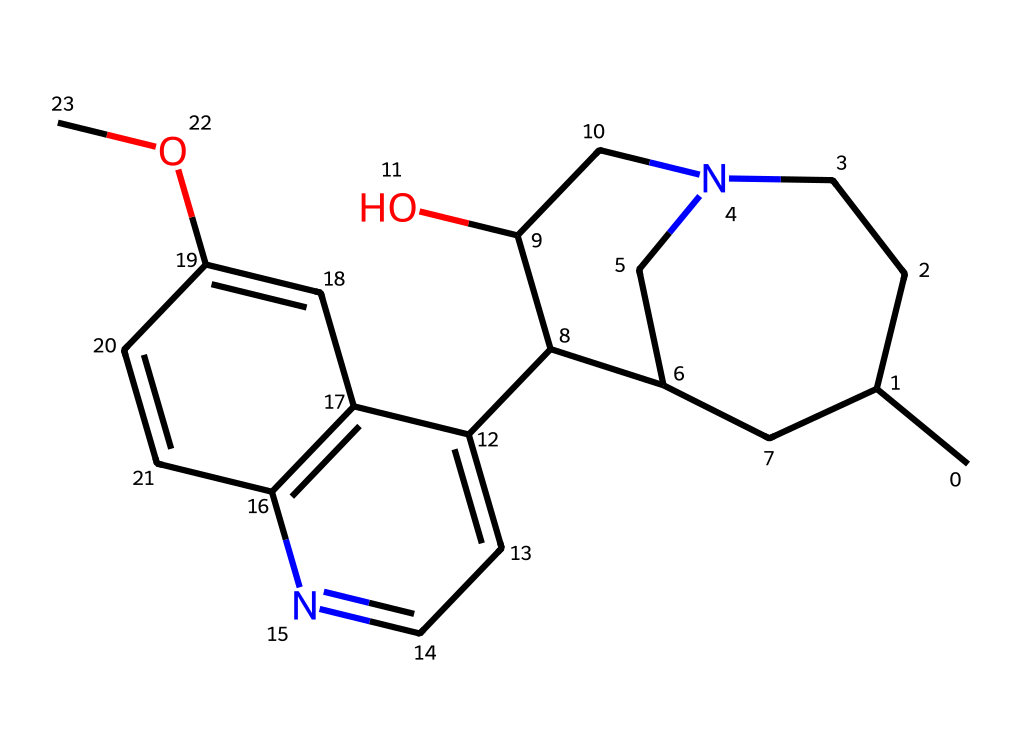how many carbon atoms are in quinine? By analyzing the provided SMILES representation, we identify each carbon atom, which can be counted from the structure. There are 20 carbon atoms present in the molecule.
Answer: 20 what type of compound is quinine? Quinine is classified as an alkaloid due to the presence of nitrogen in its structure, which is characteristic of such compounds.
Answer: alkaloid what functional group is present in quinine? The presence of the hydroxy group (-OH) in the structure indicates that quinine contains an alcohol functional group, which is commonly found in many medicinal compounds.
Answer: alcohol how many nitrogen atoms are in quinine? By examining the SMILES string, we count the nitrogen atoms included in the structure. Quinine contains 2 nitrogen atoms.
Answer: 2 what is the ring structure present in quinine? Quinine contains multiple ring structures, specifically a bicyclic system. The presence of fused rings contributes to its complexity and biological activity as an antimalarial.
Answer: bicyclic which element in quinine contributes to its basicity? The nitrogen atoms in quinine can accept protons, leading to its basic properties, thus contributing to its overall basicity.
Answer: nitrogen 